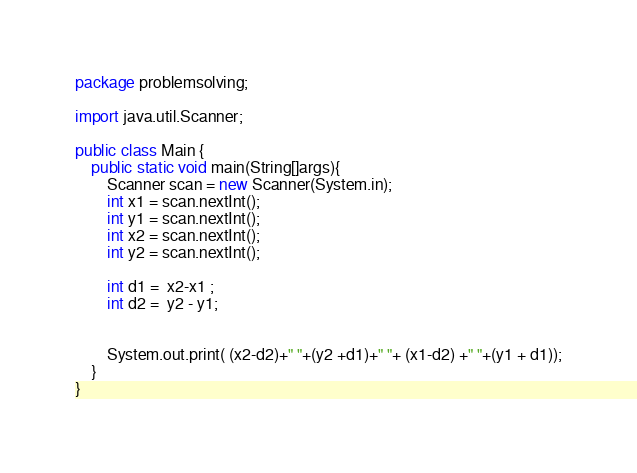<code> <loc_0><loc_0><loc_500><loc_500><_Java_>package problemsolving;

import java.util.Scanner;

public class Main {
    public static void main(String[]args){
        Scanner scan = new Scanner(System.in);
        int x1 = scan.nextInt();
        int y1 = scan.nextInt();
        int x2 = scan.nextInt();
        int y2 = scan.nextInt();
        
        int d1 =  x2-x1 ;
        int d2 =  y2 - y1;
        

        System.out.print( (x2-d2)+" "+(y2 +d1)+" "+ (x1-d2) +" "+(y1 + d1));
    }
}
</code> 